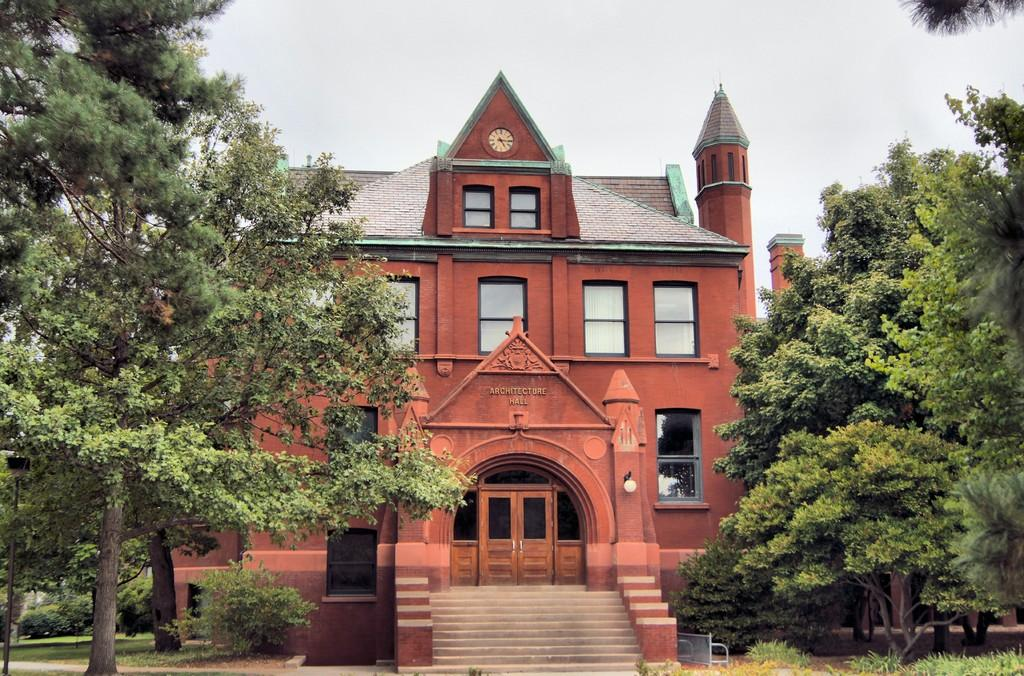What type of vegetation can be seen on both sides of the image? There are trees on both sides of the image. What type of structure is present in the image? There is a house structure in the image. What other type of vegetation can be seen in the image? There are plants in the image. What can be seen in the background of the image? The sky is visible in the background of the image. What type of drink is being offered to the trees in the image? There is no drink being offered to the trees in the image, as trees do not consume drinks. What type of wave can be seen in the image? There is no wave present in the image, as it is not a coastal or water-related scene. 